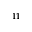<formula> <loc_0><loc_0><loc_500><loc_500>^ { 1 1 }</formula> 